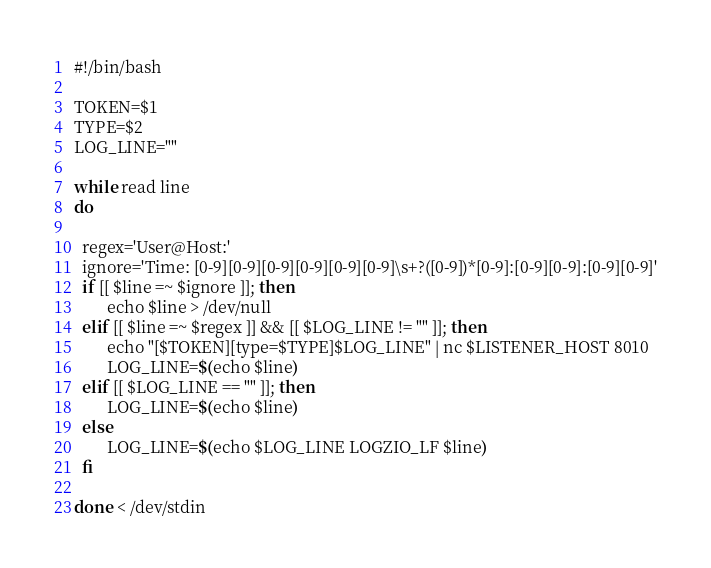<code> <loc_0><loc_0><loc_500><loc_500><_Bash_>#!/bin/bash

TOKEN=$1
TYPE=$2
LOG_LINE=""

while read line
do

  regex='User@Host:'
  ignore='Time: [0-9][0-9][0-9][0-9][0-9][0-9]\s+?([0-9])*[0-9]:[0-9][0-9]:[0-9][0-9]'
  if [[ $line =~ $ignore ]]; then
        echo $line > /dev/null
  elif [[ $line =~ $regex ]] && [[ $LOG_LINE != "" ]]; then
        echo "[$TOKEN][type=$TYPE]$LOG_LINE" | nc $LISTENER_HOST 8010
        LOG_LINE=$(echo $line)
  elif [[ $LOG_LINE == "" ]]; then
        LOG_LINE=$(echo $line)
  else
        LOG_LINE=$(echo $LOG_LINE LOGZIO_LF $line)
  fi

done < /dev/stdin</code> 